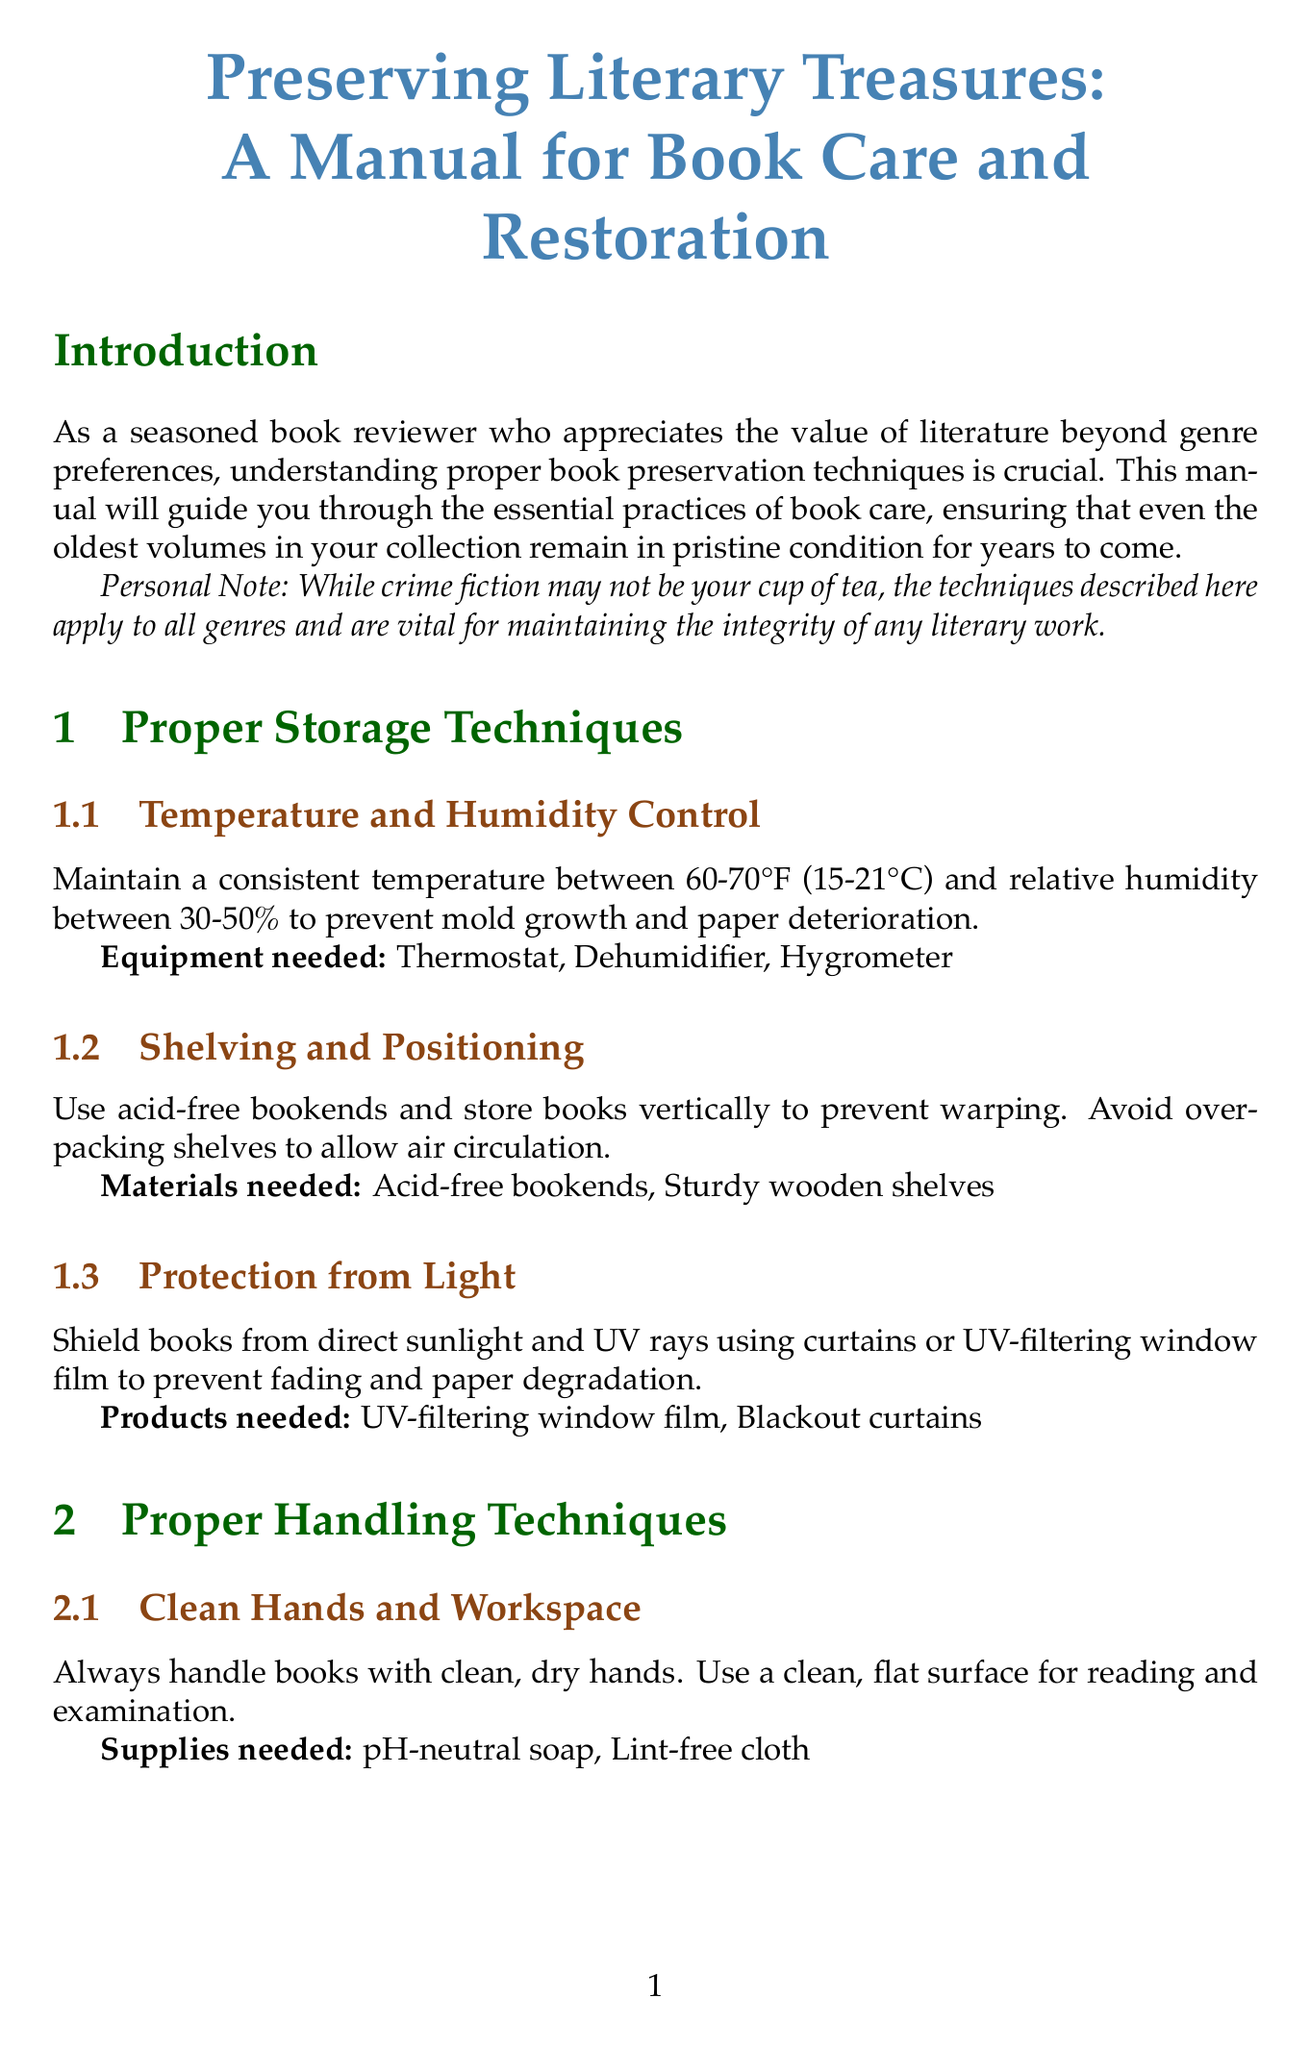What is the recommended temperature range for book storage? The document states to maintain a consistent temperature between 60-70°F (15-21°C) to prevent damage.
Answer: 60-70°F (15-21°C) What equipment is needed for humidity control? The document lists three specific pieces of equipment for humidity control: Thermostat, Dehumidifier, Hygrometer.
Answer: Thermostat, Dehumidifier, Hygrometer What is the ideal relative humidity percentage for storing books? The manual indicates the ideal relative humidity should be between 30-50% to prevent mold growth and paper deterioration.
Answer: 30-50% What protective measure is suggested to shield books from light? The manual recommends using curtains or UV-filtering window film to protect books from direct sunlight and UV rays.
Answer: Curtains or UV-filtering window film Why should you avoid licking fingers to turn pages? The document explains that licking fingers can introduce harmful oils and bacteria to the pages.
Answer: Harmful oils and bacteria What should be used to repair loose pages in books? The document suggests using archival-quality materials such as archival repair tape, wheat starch paste, and Japanese tissue paper for page repairs.
Answer: Archival repair tape, wheat starch paste, Japanese tissue paper What is an example of digital preservation mentioned in the manual? The manual discusses creating high-resolution scans of rare or fragile books as a method of digital preservation.
Answer: High-resolution scans How should bookmarks and inserts be stored? The document advises removing and storing bookmarks and inserts separately in acid-free archival folders to prevent damage.
Answer: Acid-free archival folders What is the primary purpose of the manual? The manual aims to guide users through essential practices of book care to maintain the integrity of literary works.
Answer: Maintain the integrity of literary works 